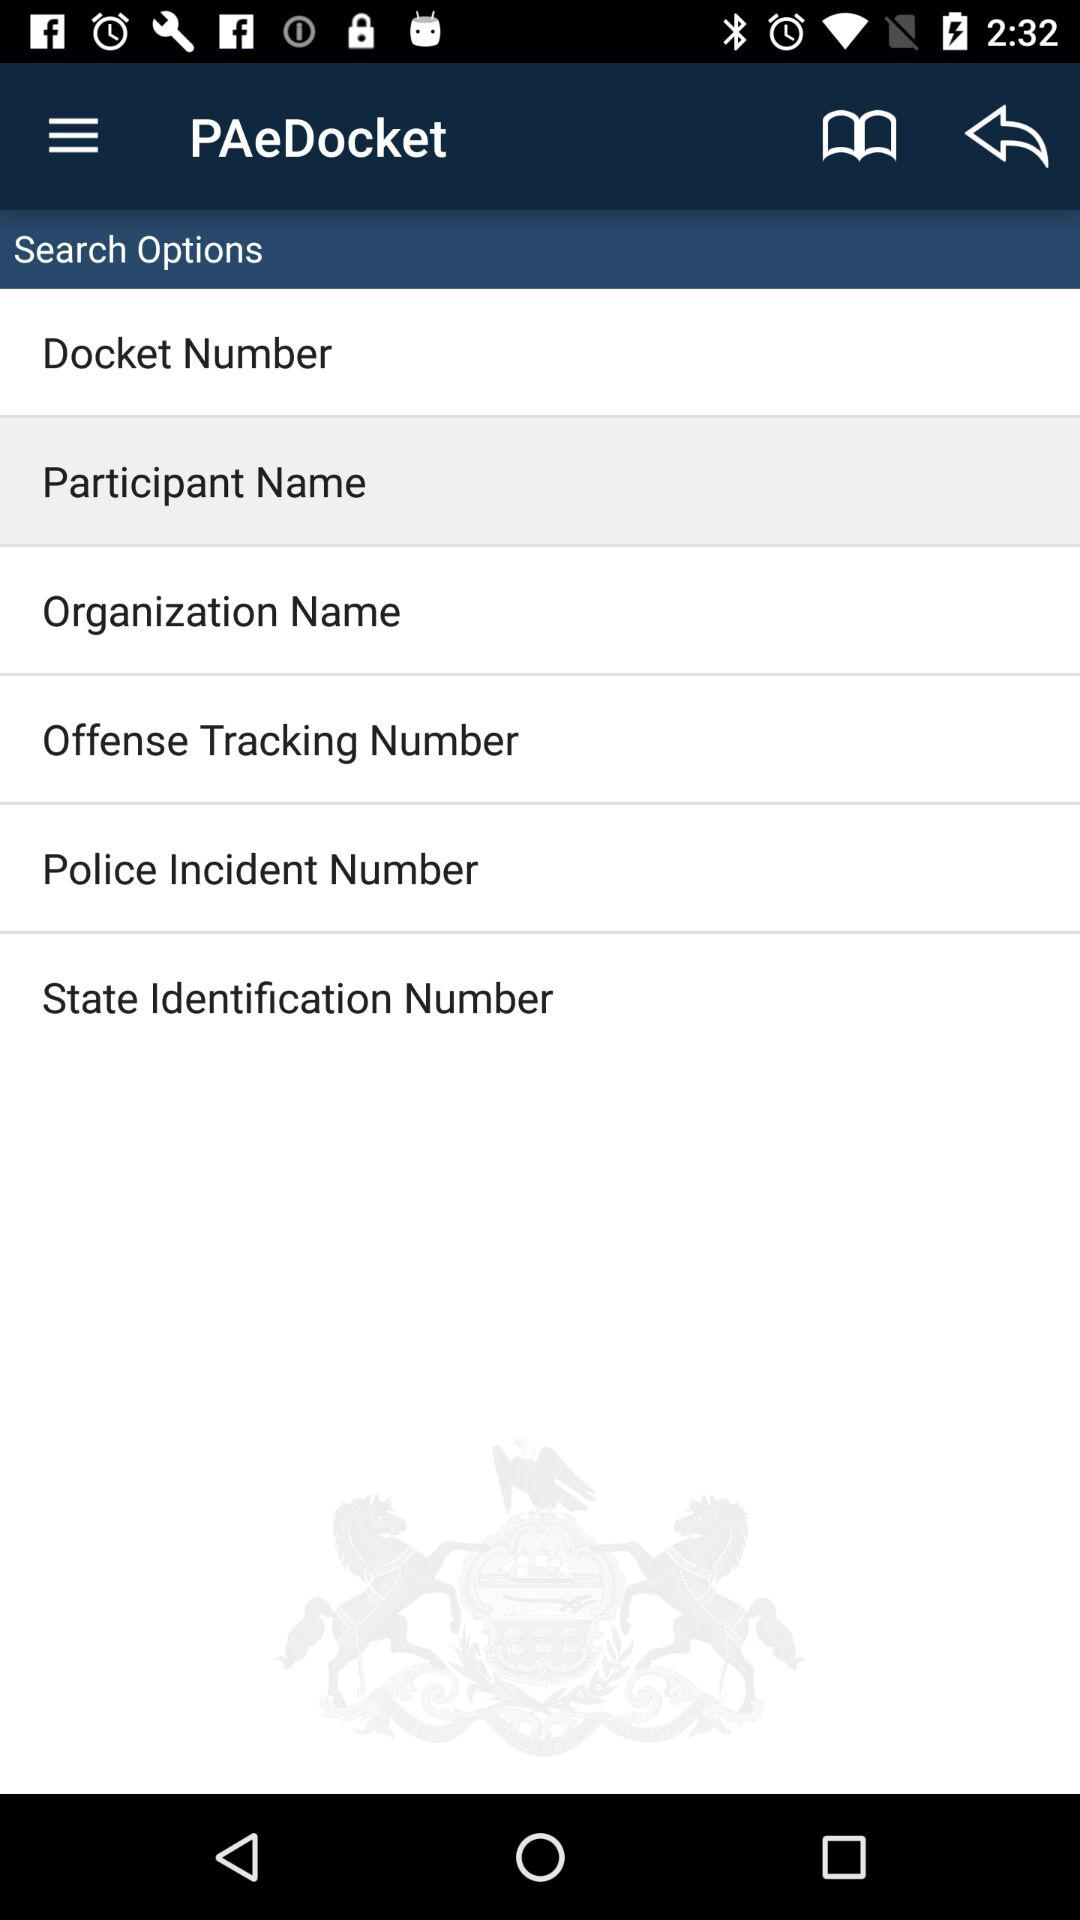What option is currently selected? The currently selected option is "Participant Name". 